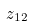Convert formula to latex. <formula><loc_0><loc_0><loc_500><loc_500>z _ { 1 2 }</formula> 